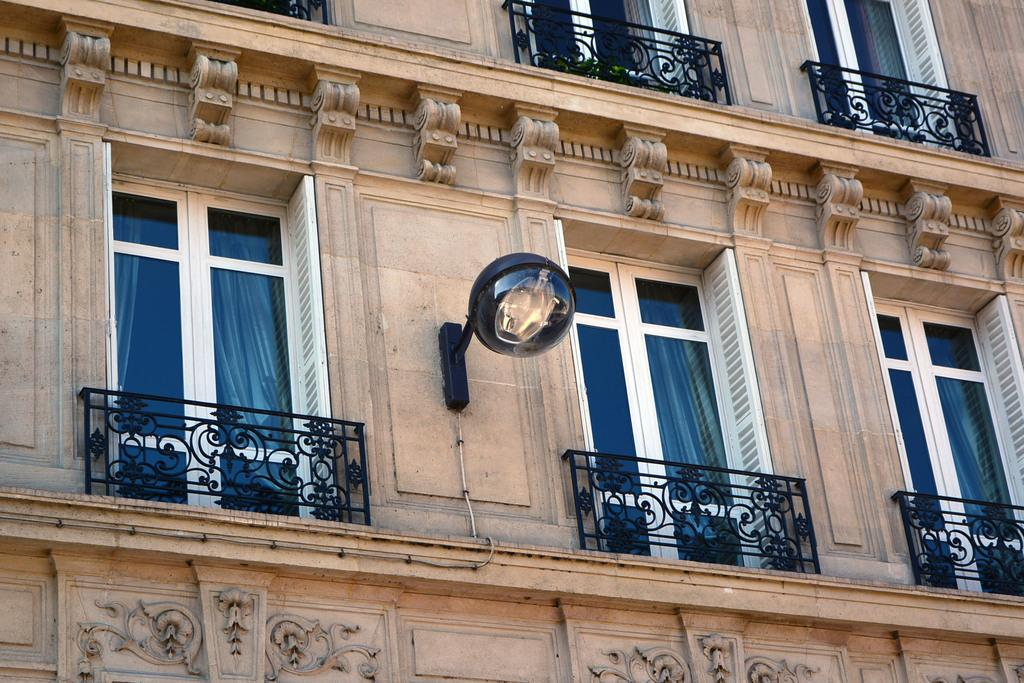What is the main structure in the picture? There is a building in the picture. What features can be observed on the building? The building has windows and grills. Is there any additional element attached to the building? Yes, there is a light attached to the wall of the building. Can you tell me how many aunts are standing near the building in the image? There is no mention of any aunts in the image, so it is not possible to answer that question. 